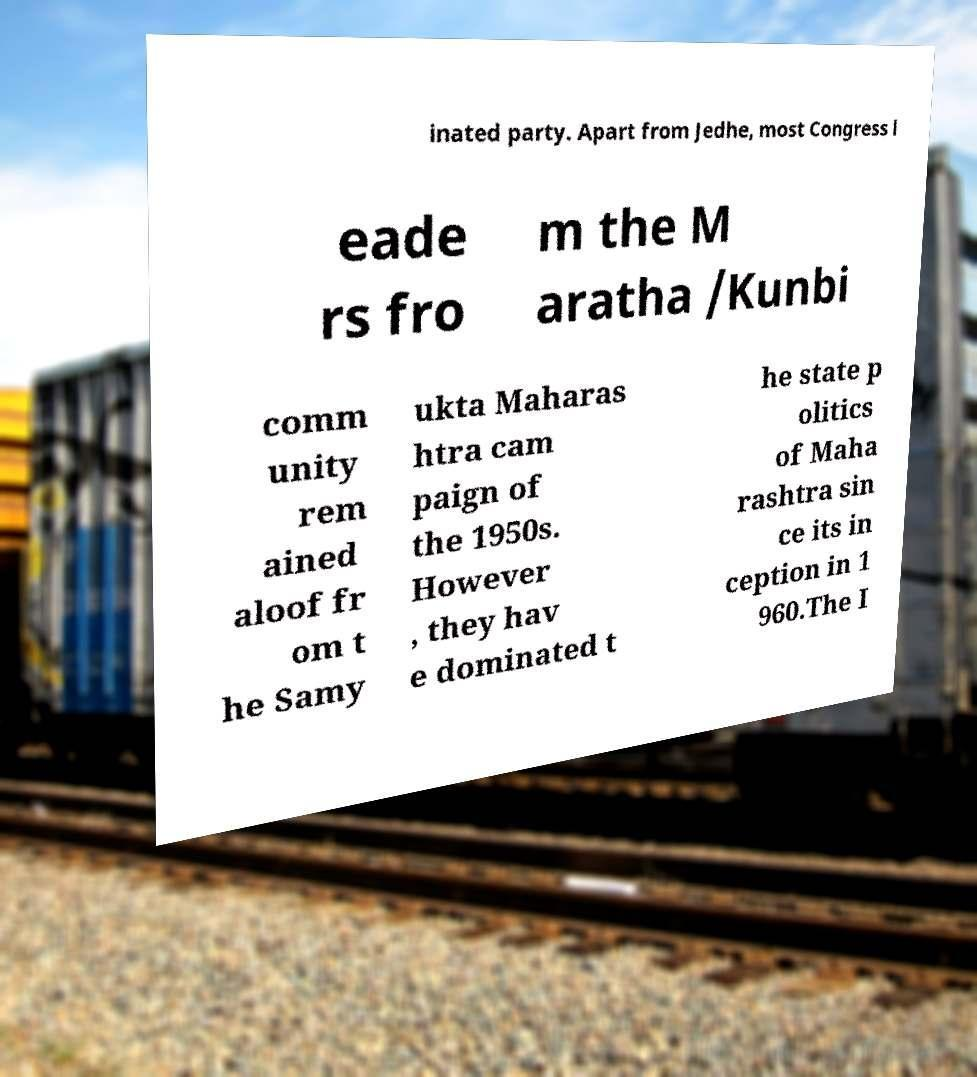Please read and relay the text visible in this image. What does it say? inated party. Apart from Jedhe, most Congress l eade rs fro m the M aratha /Kunbi comm unity rem ained aloof fr om t he Samy ukta Maharas htra cam paign of the 1950s. However , they hav e dominated t he state p olitics of Maha rashtra sin ce its in ception in 1 960.The I 